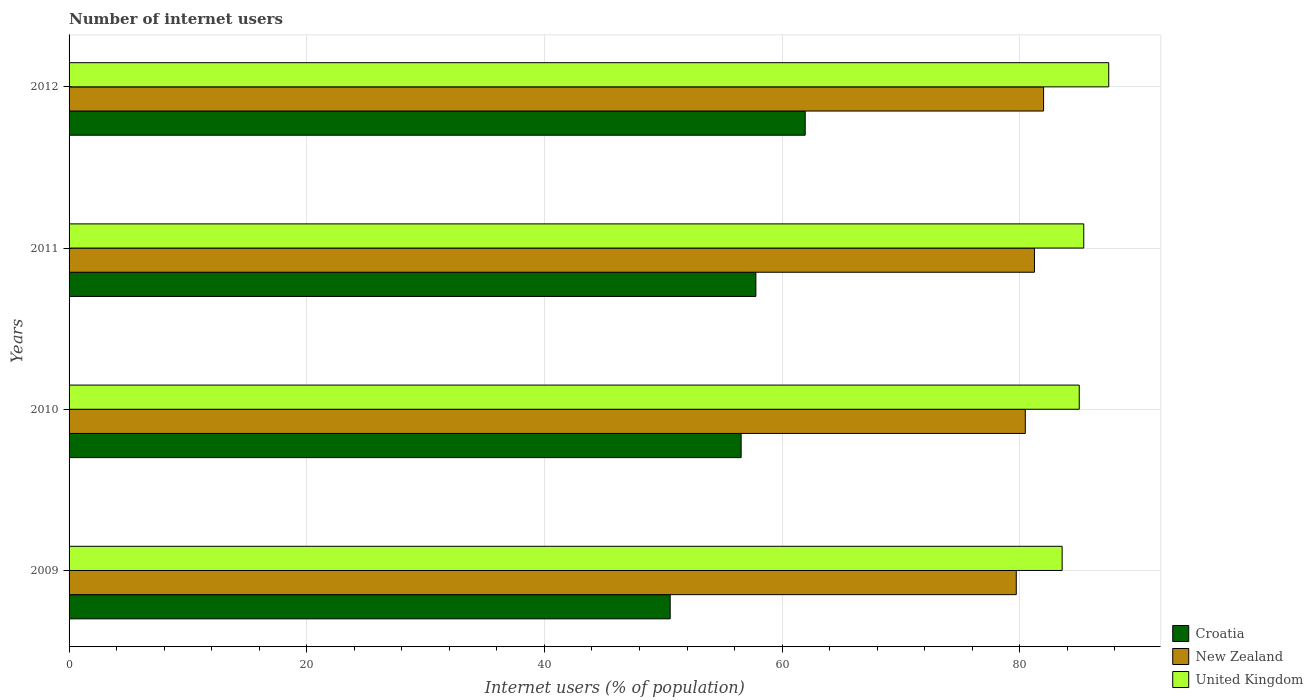How many different coloured bars are there?
Offer a terse response. 3. What is the number of internet users in Croatia in 2010?
Your answer should be very brief. 56.55. Across all years, what is the minimum number of internet users in Croatia?
Make the answer very short. 50.58. In which year was the number of internet users in United Kingdom maximum?
Provide a succinct answer. 2012. What is the total number of internet users in United Kingdom in the graph?
Ensure brevity in your answer.  341.42. What is the difference between the number of internet users in United Kingdom in 2010 and that in 2012?
Give a very brief answer. -2.48. What is the difference between the number of internet users in New Zealand in 2010 and the number of internet users in United Kingdom in 2012?
Offer a terse response. -7.02. What is the average number of internet users in United Kingdom per year?
Provide a succinct answer. 85.35. In the year 2012, what is the difference between the number of internet users in Croatia and number of internet users in New Zealand?
Offer a very short reply. -20.06. In how many years, is the number of internet users in United Kingdom greater than 16 %?
Offer a terse response. 4. What is the ratio of the number of internet users in Croatia in 2009 to that in 2011?
Offer a terse response. 0.88. Is the number of internet users in Croatia in 2009 less than that in 2012?
Keep it short and to the point. Yes. What is the difference between the highest and the second highest number of internet users in United Kingdom?
Provide a succinct answer. 2.1. What is the difference between the highest and the lowest number of internet users in United Kingdom?
Your answer should be compact. 3.92. In how many years, is the number of internet users in United Kingdom greater than the average number of internet users in United Kingdom taken over all years?
Your answer should be very brief. 2. Is the sum of the number of internet users in Croatia in 2010 and 2012 greater than the maximum number of internet users in New Zealand across all years?
Your answer should be compact. Yes. What does the 3rd bar from the top in 2011 represents?
Give a very brief answer. Croatia. What does the 1st bar from the bottom in 2011 represents?
Offer a very short reply. Croatia. Is it the case that in every year, the sum of the number of internet users in United Kingdom and number of internet users in New Zealand is greater than the number of internet users in Croatia?
Provide a short and direct response. Yes. Are the values on the major ticks of X-axis written in scientific E-notation?
Your response must be concise. No. How are the legend labels stacked?
Provide a succinct answer. Vertical. What is the title of the graph?
Offer a very short reply. Number of internet users. What is the label or title of the X-axis?
Offer a very short reply. Internet users (% of population). What is the label or title of the Y-axis?
Your answer should be very brief. Years. What is the Internet users (% of population) of Croatia in 2009?
Ensure brevity in your answer.  50.58. What is the Internet users (% of population) in New Zealand in 2009?
Your answer should be very brief. 79.7. What is the Internet users (% of population) of United Kingdom in 2009?
Your answer should be very brief. 83.56. What is the Internet users (% of population) of Croatia in 2010?
Keep it short and to the point. 56.55. What is the Internet users (% of population) of New Zealand in 2010?
Provide a short and direct response. 80.46. What is the Internet users (% of population) of United Kingdom in 2010?
Offer a terse response. 85. What is the Internet users (% of population) of Croatia in 2011?
Ensure brevity in your answer.  57.79. What is the Internet users (% of population) in New Zealand in 2011?
Keep it short and to the point. 81.23. What is the Internet users (% of population) of United Kingdom in 2011?
Make the answer very short. 85.38. What is the Internet users (% of population) of Croatia in 2012?
Make the answer very short. 61.94. What is the Internet users (% of population) in New Zealand in 2012?
Your answer should be compact. 82. What is the Internet users (% of population) of United Kingdom in 2012?
Give a very brief answer. 87.48. Across all years, what is the maximum Internet users (% of population) in Croatia?
Your answer should be very brief. 61.94. Across all years, what is the maximum Internet users (% of population) of New Zealand?
Your answer should be compact. 82. Across all years, what is the maximum Internet users (% of population) in United Kingdom?
Your answer should be compact. 87.48. Across all years, what is the minimum Internet users (% of population) of Croatia?
Make the answer very short. 50.58. Across all years, what is the minimum Internet users (% of population) of New Zealand?
Your response must be concise. 79.7. Across all years, what is the minimum Internet users (% of population) in United Kingdom?
Provide a succinct answer. 83.56. What is the total Internet users (% of population) of Croatia in the graph?
Make the answer very short. 226.86. What is the total Internet users (% of population) of New Zealand in the graph?
Your answer should be very brief. 323.39. What is the total Internet users (% of population) in United Kingdom in the graph?
Make the answer very short. 341.42. What is the difference between the Internet users (% of population) of Croatia in 2009 and that in 2010?
Your answer should be very brief. -5.97. What is the difference between the Internet users (% of population) in New Zealand in 2009 and that in 2010?
Offer a terse response. -0.76. What is the difference between the Internet users (% of population) in United Kingdom in 2009 and that in 2010?
Make the answer very short. -1.44. What is the difference between the Internet users (% of population) in Croatia in 2009 and that in 2011?
Make the answer very short. -7.21. What is the difference between the Internet users (% of population) of New Zealand in 2009 and that in 2011?
Provide a short and direct response. -1.53. What is the difference between the Internet users (% of population) in United Kingdom in 2009 and that in 2011?
Give a very brief answer. -1.82. What is the difference between the Internet users (% of population) of Croatia in 2009 and that in 2012?
Provide a succinct answer. -11.36. What is the difference between the Internet users (% of population) in New Zealand in 2009 and that in 2012?
Provide a succinct answer. -2.3. What is the difference between the Internet users (% of population) of United Kingdom in 2009 and that in 2012?
Your answer should be compact. -3.92. What is the difference between the Internet users (% of population) in Croatia in 2010 and that in 2011?
Provide a succinct answer. -1.24. What is the difference between the Internet users (% of population) in New Zealand in 2010 and that in 2011?
Your response must be concise. -0.77. What is the difference between the Internet users (% of population) of United Kingdom in 2010 and that in 2011?
Your answer should be compact. -0.38. What is the difference between the Internet users (% of population) in Croatia in 2010 and that in 2012?
Offer a terse response. -5.39. What is the difference between the Internet users (% of population) in New Zealand in 2010 and that in 2012?
Your response must be concise. -1.54. What is the difference between the Internet users (% of population) in United Kingdom in 2010 and that in 2012?
Make the answer very short. -2.48. What is the difference between the Internet users (% of population) in Croatia in 2011 and that in 2012?
Keep it short and to the point. -4.15. What is the difference between the Internet users (% of population) in New Zealand in 2011 and that in 2012?
Provide a succinct answer. -0.77. What is the difference between the Internet users (% of population) in United Kingdom in 2011 and that in 2012?
Offer a very short reply. -2.1. What is the difference between the Internet users (% of population) in Croatia in 2009 and the Internet users (% of population) in New Zealand in 2010?
Ensure brevity in your answer.  -29.88. What is the difference between the Internet users (% of population) of Croatia in 2009 and the Internet users (% of population) of United Kingdom in 2010?
Your answer should be very brief. -34.42. What is the difference between the Internet users (% of population) of New Zealand in 2009 and the Internet users (% of population) of United Kingdom in 2010?
Your response must be concise. -5.3. What is the difference between the Internet users (% of population) in Croatia in 2009 and the Internet users (% of population) in New Zealand in 2011?
Provide a short and direct response. -30.65. What is the difference between the Internet users (% of population) in Croatia in 2009 and the Internet users (% of population) in United Kingdom in 2011?
Ensure brevity in your answer.  -34.8. What is the difference between the Internet users (% of population) of New Zealand in 2009 and the Internet users (% of population) of United Kingdom in 2011?
Keep it short and to the point. -5.68. What is the difference between the Internet users (% of population) of Croatia in 2009 and the Internet users (% of population) of New Zealand in 2012?
Provide a succinct answer. -31.42. What is the difference between the Internet users (% of population) in Croatia in 2009 and the Internet users (% of population) in United Kingdom in 2012?
Your answer should be compact. -36.9. What is the difference between the Internet users (% of population) in New Zealand in 2009 and the Internet users (% of population) in United Kingdom in 2012?
Offer a terse response. -7.78. What is the difference between the Internet users (% of population) of Croatia in 2010 and the Internet users (% of population) of New Zealand in 2011?
Give a very brief answer. -24.68. What is the difference between the Internet users (% of population) of Croatia in 2010 and the Internet users (% of population) of United Kingdom in 2011?
Ensure brevity in your answer.  -28.83. What is the difference between the Internet users (% of population) in New Zealand in 2010 and the Internet users (% of population) in United Kingdom in 2011?
Your answer should be compact. -4.92. What is the difference between the Internet users (% of population) in Croatia in 2010 and the Internet users (% of population) in New Zealand in 2012?
Your response must be concise. -25.45. What is the difference between the Internet users (% of population) of Croatia in 2010 and the Internet users (% of population) of United Kingdom in 2012?
Your response must be concise. -30.93. What is the difference between the Internet users (% of population) in New Zealand in 2010 and the Internet users (% of population) in United Kingdom in 2012?
Offer a terse response. -7.02. What is the difference between the Internet users (% of population) in Croatia in 2011 and the Internet users (% of population) in New Zealand in 2012?
Keep it short and to the point. -24.21. What is the difference between the Internet users (% of population) in Croatia in 2011 and the Internet users (% of population) in United Kingdom in 2012?
Provide a short and direct response. -29.69. What is the difference between the Internet users (% of population) in New Zealand in 2011 and the Internet users (% of population) in United Kingdom in 2012?
Your response must be concise. -6.25. What is the average Internet users (% of population) in Croatia per year?
Give a very brief answer. 56.72. What is the average Internet users (% of population) of New Zealand per year?
Provide a succinct answer. 80.85. What is the average Internet users (% of population) in United Kingdom per year?
Give a very brief answer. 85.36. In the year 2009, what is the difference between the Internet users (% of population) of Croatia and Internet users (% of population) of New Zealand?
Your response must be concise. -29.12. In the year 2009, what is the difference between the Internet users (% of population) of Croatia and Internet users (% of population) of United Kingdom?
Provide a succinct answer. -32.98. In the year 2009, what is the difference between the Internet users (% of population) of New Zealand and Internet users (% of population) of United Kingdom?
Ensure brevity in your answer.  -3.86. In the year 2010, what is the difference between the Internet users (% of population) of Croatia and Internet users (% of population) of New Zealand?
Your response must be concise. -23.91. In the year 2010, what is the difference between the Internet users (% of population) of Croatia and Internet users (% of population) of United Kingdom?
Ensure brevity in your answer.  -28.45. In the year 2010, what is the difference between the Internet users (% of population) in New Zealand and Internet users (% of population) in United Kingdom?
Provide a succinct answer. -4.54. In the year 2011, what is the difference between the Internet users (% of population) of Croatia and Internet users (% of population) of New Zealand?
Your answer should be compact. -23.44. In the year 2011, what is the difference between the Internet users (% of population) in Croatia and Internet users (% of population) in United Kingdom?
Offer a terse response. -27.59. In the year 2011, what is the difference between the Internet users (% of population) in New Zealand and Internet users (% of population) in United Kingdom?
Offer a terse response. -4.15. In the year 2012, what is the difference between the Internet users (% of population) of Croatia and Internet users (% of population) of New Zealand?
Offer a very short reply. -20.06. In the year 2012, what is the difference between the Internet users (% of population) in Croatia and Internet users (% of population) in United Kingdom?
Your answer should be very brief. -25.54. In the year 2012, what is the difference between the Internet users (% of population) of New Zealand and Internet users (% of population) of United Kingdom?
Offer a very short reply. -5.48. What is the ratio of the Internet users (% of population) of Croatia in 2009 to that in 2010?
Your answer should be very brief. 0.89. What is the ratio of the Internet users (% of population) of New Zealand in 2009 to that in 2010?
Offer a very short reply. 0.99. What is the ratio of the Internet users (% of population) in United Kingdom in 2009 to that in 2010?
Give a very brief answer. 0.98. What is the ratio of the Internet users (% of population) in Croatia in 2009 to that in 2011?
Offer a terse response. 0.88. What is the ratio of the Internet users (% of population) of New Zealand in 2009 to that in 2011?
Keep it short and to the point. 0.98. What is the ratio of the Internet users (% of population) of United Kingdom in 2009 to that in 2011?
Your answer should be very brief. 0.98. What is the ratio of the Internet users (% of population) in Croatia in 2009 to that in 2012?
Your answer should be very brief. 0.82. What is the ratio of the Internet users (% of population) in United Kingdom in 2009 to that in 2012?
Offer a very short reply. 0.96. What is the ratio of the Internet users (% of population) of Croatia in 2010 to that in 2011?
Provide a short and direct response. 0.98. What is the ratio of the Internet users (% of population) in New Zealand in 2010 to that in 2011?
Keep it short and to the point. 0.99. What is the ratio of the Internet users (% of population) of New Zealand in 2010 to that in 2012?
Provide a short and direct response. 0.98. What is the ratio of the Internet users (% of population) of United Kingdom in 2010 to that in 2012?
Give a very brief answer. 0.97. What is the ratio of the Internet users (% of population) in Croatia in 2011 to that in 2012?
Provide a succinct answer. 0.93. What is the ratio of the Internet users (% of population) of New Zealand in 2011 to that in 2012?
Offer a terse response. 0.99. What is the ratio of the Internet users (% of population) in United Kingdom in 2011 to that in 2012?
Ensure brevity in your answer.  0.98. What is the difference between the highest and the second highest Internet users (% of population) in Croatia?
Your response must be concise. 4.15. What is the difference between the highest and the second highest Internet users (% of population) in New Zealand?
Your response must be concise. 0.77. What is the difference between the highest and the second highest Internet users (% of population) in United Kingdom?
Keep it short and to the point. 2.1. What is the difference between the highest and the lowest Internet users (% of population) of Croatia?
Offer a very short reply. 11.36. What is the difference between the highest and the lowest Internet users (% of population) of New Zealand?
Give a very brief answer. 2.3. What is the difference between the highest and the lowest Internet users (% of population) of United Kingdom?
Offer a terse response. 3.92. 